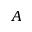<formula> <loc_0><loc_0><loc_500><loc_500>A</formula> 